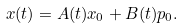<formula> <loc_0><loc_0><loc_500><loc_500>x ( t ) = A ( t ) x _ { 0 } + B ( t ) p _ { 0 } .</formula> 